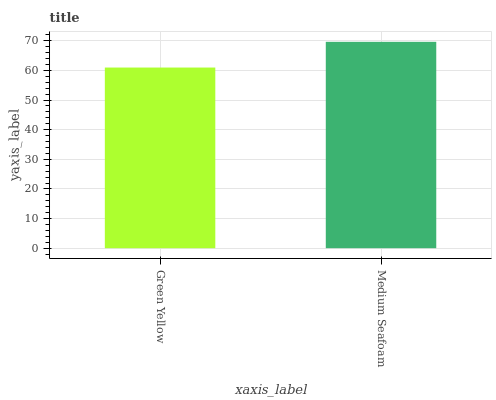Is Green Yellow the minimum?
Answer yes or no. Yes. Is Medium Seafoam the maximum?
Answer yes or no. Yes. Is Medium Seafoam the minimum?
Answer yes or no. No. Is Medium Seafoam greater than Green Yellow?
Answer yes or no. Yes. Is Green Yellow less than Medium Seafoam?
Answer yes or no. Yes. Is Green Yellow greater than Medium Seafoam?
Answer yes or no. No. Is Medium Seafoam less than Green Yellow?
Answer yes or no. No. Is Medium Seafoam the high median?
Answer yes or no. Yes. Is Green Yellow the low median?
Answer yes or no. Yes. Is Green Yellow the high median?
Answer yes or no. No. Is Medium Seafoam the low median?
Answer yes or no. No. 